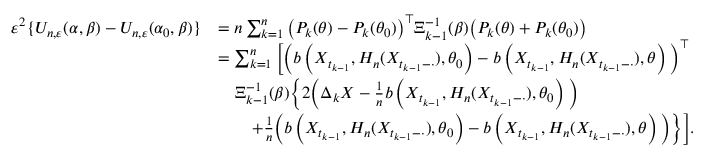Convert formula to latex. <formula><loc_0><loc_0><loc_500><loc_500>\begin{array} { r l } { \varepsilon ^ { 2 } \{ U _ { n , \varepsilon } ( \alpha , \beta ) - U _ { n , \varepsilon } ( \alpha _ { 0 } , \beta ) \} } & { = n \sum _ { k = 1 } ^ { n } \left ( P _ { k } ( \theta ) - P _ { k } ( \theta _ { 0 } ) \right ) ^ { \top } \Xi _ { k - 1 } ^ { - 1 } ( \beta ) \left ( P _ { k } ( \theta ) + P _ { k } ( \theta _ { 0 } ) \right ) } \\ & { = \sum _ { k = 1 } ^ { n } \left [ \left ( b \left ( X _ { t _ { k - 1 } } , H _ { n } ( X _ { t _ { k - 1 } - \cdot } ) , \theta _ { 0 } \right ) - b \left ( X _ { t _ { k - 1 } } , H _ { n } ( X _ { t _ { k - 1 } - \cdot } ) , \theta \right ) \right ) ^ { \top } } \\ & { \quad \Xi _ { k - 1 } ^ { - 1 } ( \beta ) \left \{ 2 \left ( \Delta _ { k } X - \frac { 1 } { n } b \left ( X _ { t _ { k - 1 } } , H _ { n } ( X _ { t _ { k - 1 } - \cdot } ) , \theta _ { 0 } \right ) \right ) } \\ & { \quad + \frac { 1 } { n } \left ( b \left ( X _ { t _ { k - 1 } } , H _ { n } ( X _ { t _ { k - 1 } - \cdot } ) , \theta _ { 0 } \right ) - b \left ( X _ { t _ { k - 1 } } , H _ { n } ( X _ { t _ { k - 1 } - \cdot } ) , \theta \right ) \right ) \right \} \right ] . } \end{array}</formula> 